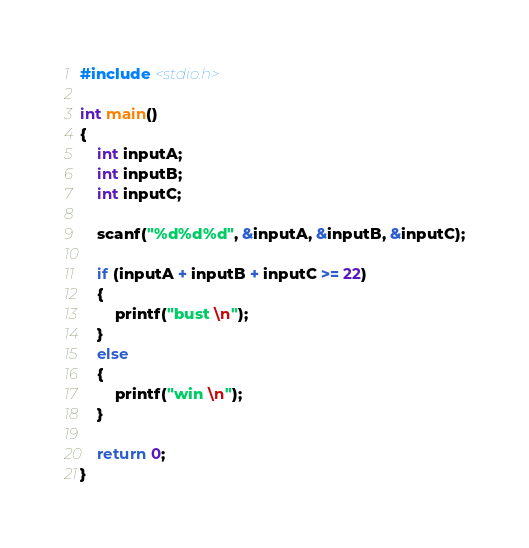Convert code to text. <code><loc_0><loc_0><loc_500><loc_500><_C_>#include <stdio.h>

int main()
{
	int inputA;
	int inputB;
	int inputC;

	scanf("%d%d%d", &inputA, &inputB, &inputC);

	if (inputA + inputB + inputC >= 22)
	{
		printf("bust \n");		
	}
	else
	{
		printf("win \n");
	}
  
	return 0;
}</code> 